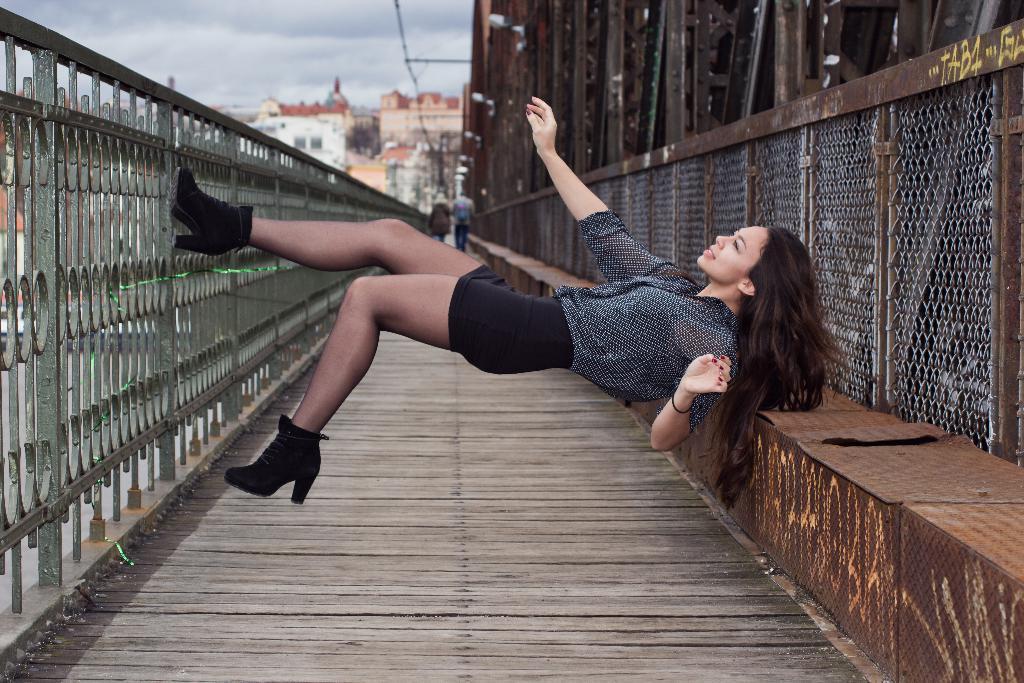Describe this image in one or two sentences. In this image in the center there is a woman. In the background there are buildings and the sky is cloudy. On the left side there is a fence. 